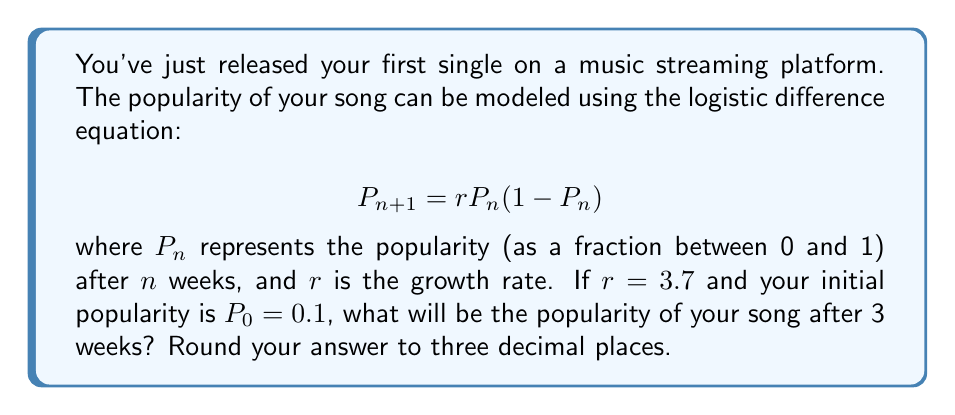Show me your answer to this math problem. Let's solve this step-by-step using the given logistic difference equation:

$$P_{n+1} = rP_n(1-P_n)$$

Given:
$r = 3.7$
$P_0 = 0.1$

Step 1: Calculate $P_1$
$$P_1 = 3.7 \cdot 0.1 \cdot (1-0.1) = 3.7 \cdot 0.1 \cdot 0.9 = 0.333$$

Step 2: Calculate $P_2$
$$P_2 = 3.7 \cdot 0.333 \cdot (1-0.333) = 3.7 \cdot 0.333 \cdot 0.667 = 0.822$$

Step 3: Calculate $P_3$
$$P_3 = 3.7 \cdot 0.822 \cdot (1-0.822) = 3.7 \cdot 0.822 \cdot 0.178 = 0.542$$

Step 4: Round to three decimal places
$0.542$ rounded to three decimal places is $0.542$

This demonstrates the butterfly effect in viral music trends, where small changes in initial conditions can lead to significant and unpredictable changes over time.
Answer: 0.542 